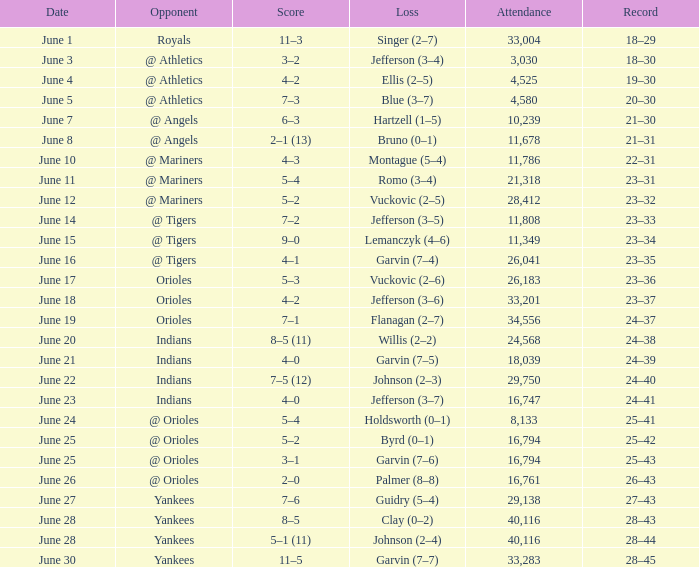Who was the opponent at the game when the record was 28–45? Yankees. 